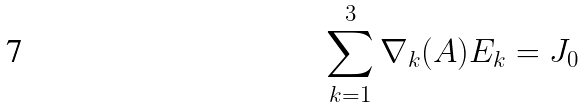<formula> <loc_0><loc_0><loc_500><loc_500>\sum _ { k = 1 } ^ { 3 } \nabla _ { k } ( A ) E _ { k } = J _ { 0 }</formula> 